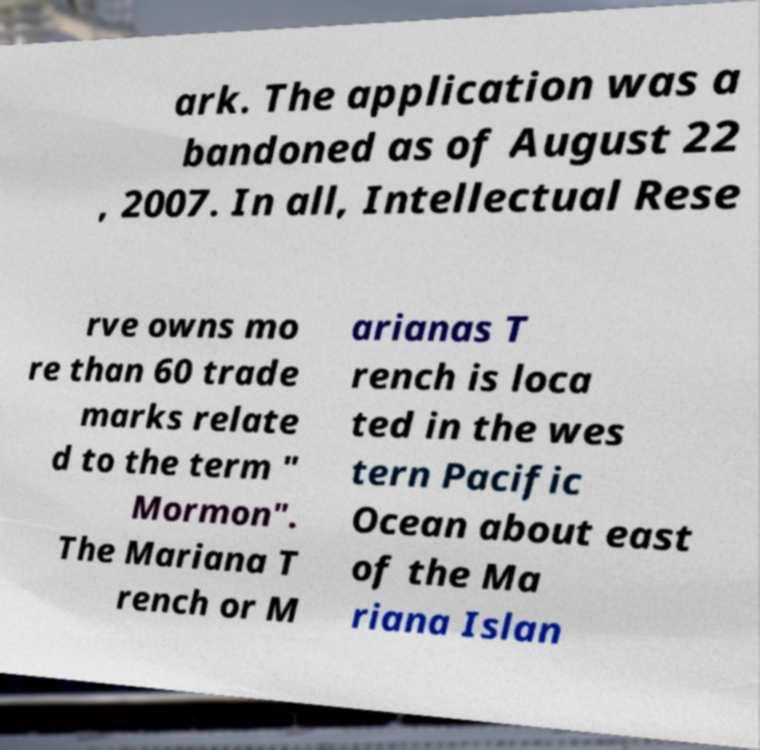Please identify and transcribe the text found in this image. ark. The application was a bandoned as of August 22 , 2007. In all, Intellectual Rese rve owns mo re than 60 trade marks relate d to the term " Mormon". The Mariana T rench or M arianas T rench is loca ted in the wes tern Pacific Ocean about east of the Ma riana Islan 